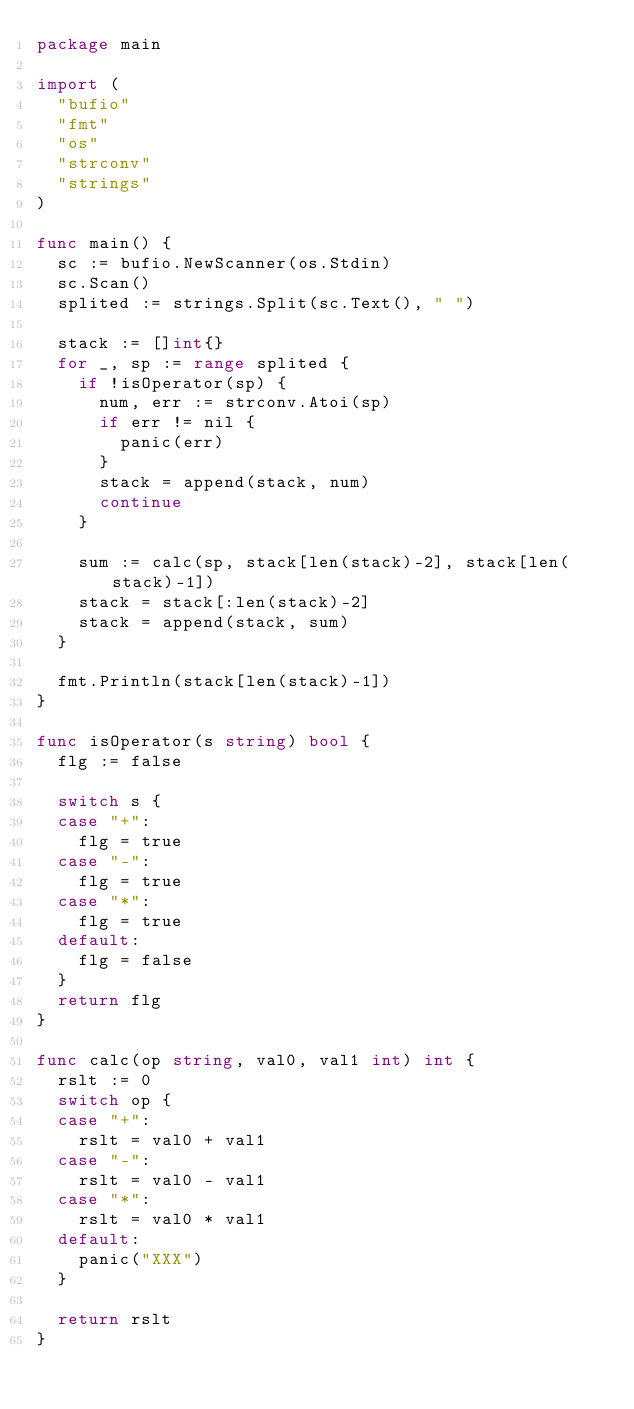Convert code to text. <code><loc_0><loc_0><loc_500><loc_500><_Go_>package main

import (
	"bufio"
	"fmt"
	"os"
	"strconv"
	"strings"
)

func main() {
	sc := bufio.NewScanner(os.Stdin)
	sc.Scan()
	splited := strings.Split(sc.Text(), " ")

	stack := []int{}
	for _, sp := range splited {
		if !isOperator(sp) {
			num, err := strconv.Atoi(sp)
			if err != nil {
				panic(err)
			}
			stack = append(stack, num)
			continue
		}

		sum := calc(sp, stack[len(stack)-2], stack[len(stack)-1])
		stack = stack[:len(stack)-2]
		stack = append(stack, sum)
	}

	fmt.Println(stack[len(stack)-1])
}

func isOperator(s string) bool {
	flg := false

	switch s {
	case "+":
		flg = true
	case "-":
		flg = true
	case "*":
		flg = true
	default:
		flg = false
	}
	return flg
}

func calc(op string, val0, val1 int) int {
	rslt := 0
	switch op {
	case "+":
		rslt = val0 + val1
	case "-":
		rslt = val0 - val1
	case "*":
		rslt = val0 * val1
	default:
		panic("XXX")
	}

	return rslt
}

</code> 